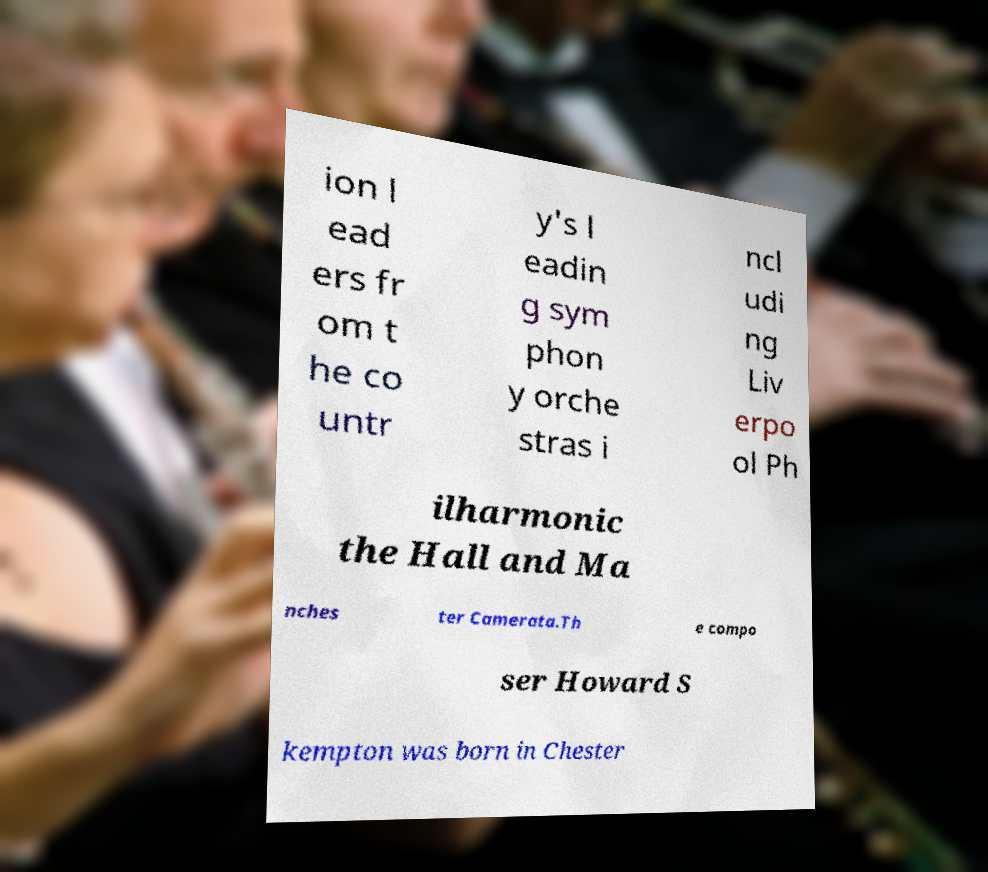There's text embedded in this image that I need extracted. Can you transcribe it verbatim? ion l ead ers fr om t he co untr y's l eadin g sym phon y orche stras i ncl udi ng Liv erpo ol Ph ilharmonic the Hall and Ma nches ter Camerata.Th e compo ser Howard S kempton was born in Chester 